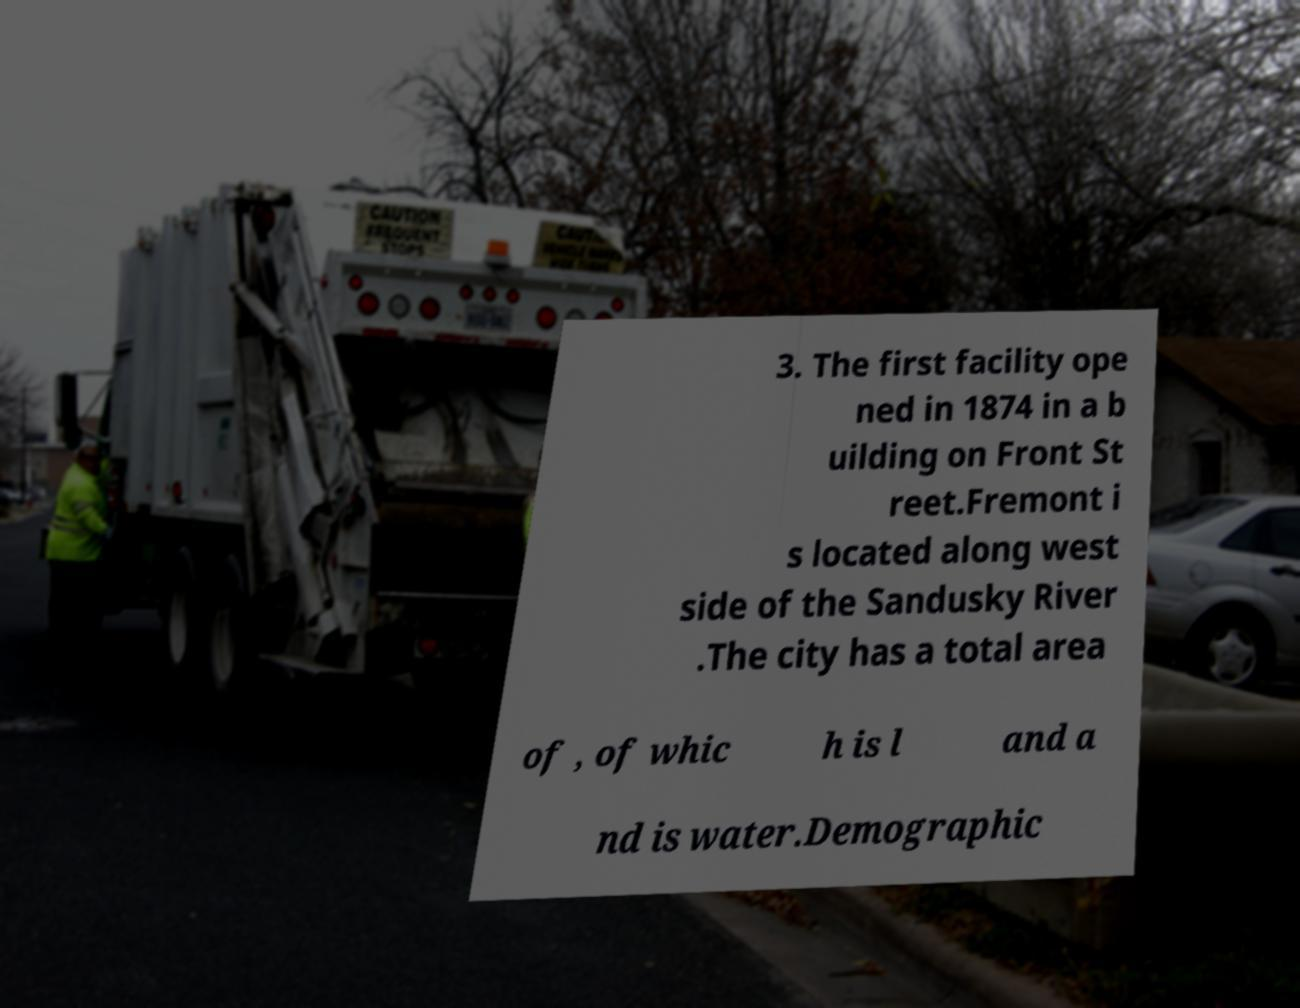Could you assist in decoding the text presented in this image and type it out clearly? 3. The first facility ope ned in 1874 in a b uilding on Front St reet.Fremont i s located along west side of the Sandusky River .The city has a total area of , of whic h is l and a nd is water.Demographic 